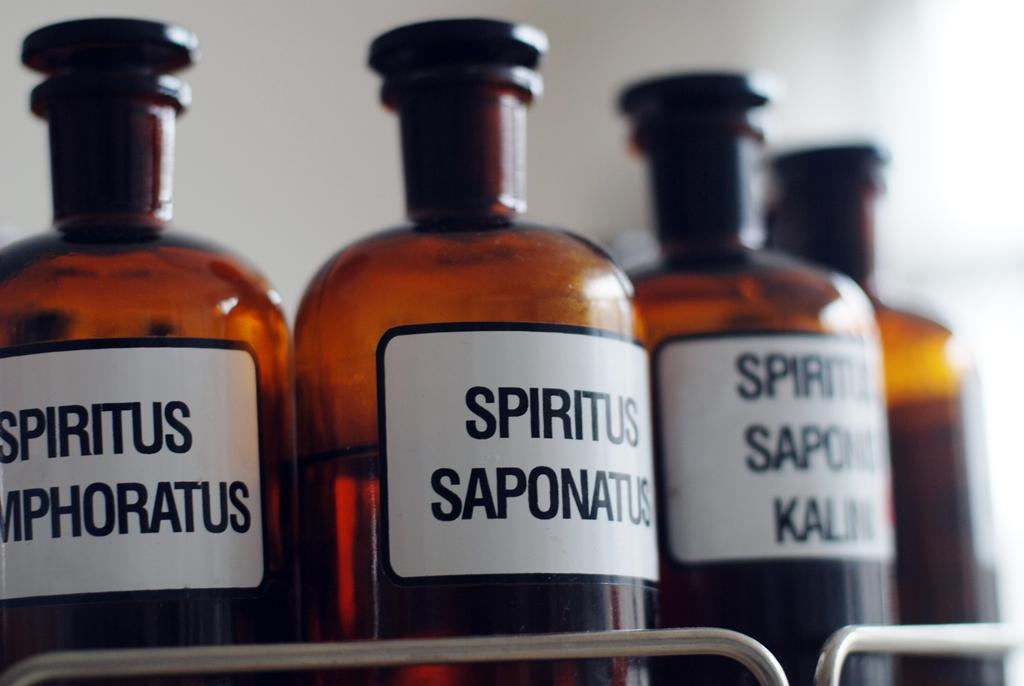<image>
Provide a brief description of the given image. A bottle of Spiritus Saponatus next to two other 